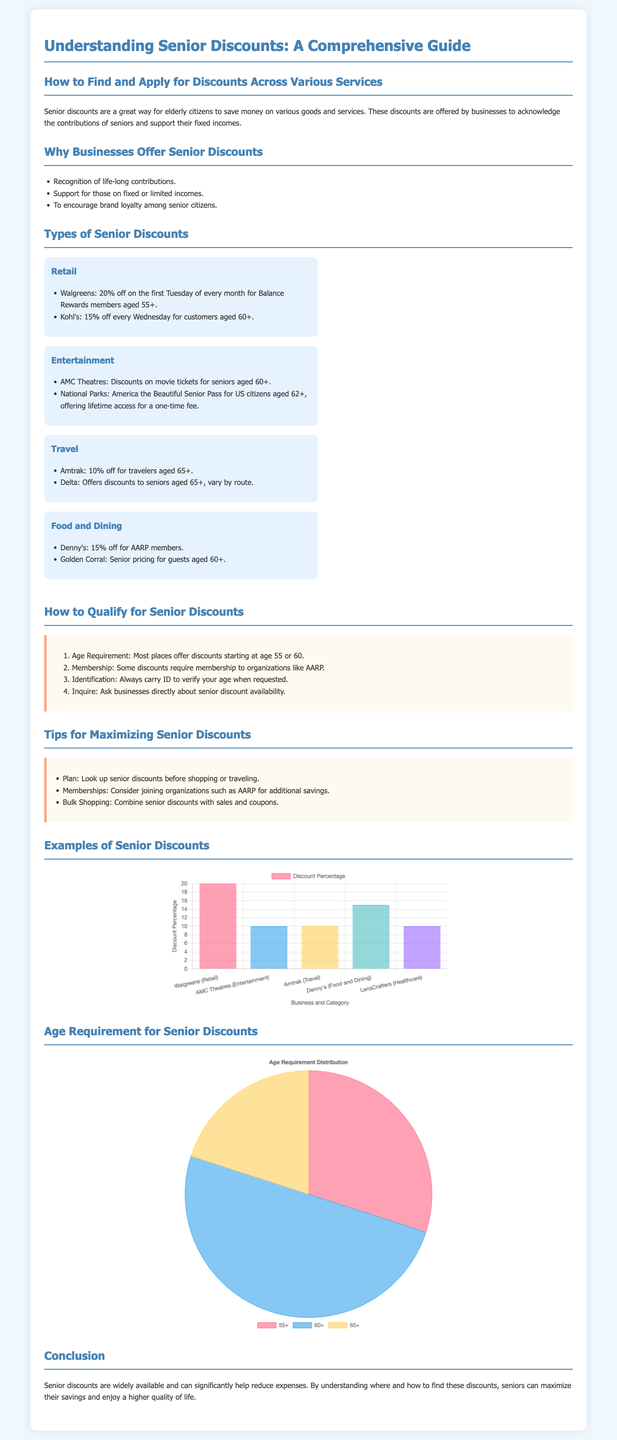What is the percentage discount offered by Walgreens? Walgreens offers a 20% discount on the first Tuesday of every month for Balance Rewards members aged 55+.
Answer: 20% What age do seniors typically qualify for discounts at Denny's? Denny's offers a 15% discount for AARP members, usually starting at age 55 or 60.
Answer: 60+ Which category does the National Parks discount fall under? The National Parks discount for seniors falls under the Entertainment category.
Answer: Entertainment What percentage discount does Amtrak provide for seniors? Amtrak offers a 10% discount for travelers aged 65 and older.
Answer: 10% What is the age distribution percentage for the 60+ category? The age requirement distribution shows that 50% of discounts are available for individuals aged 60 and older.
Answer: 50% How many steps are mentioned for qualifying for senior discounts? There are four steps listed for qualifying for senior discounts in the document.
Answer: 4 Which organization is recommended for additional savings opportunities? AARP is mentioned as a recommended organization for additional savings.
Answer: AARP What type of chart visualizes the discount percentages across business categories? A bar chart is used to visualize the discount percentages across various business categories.
Answer: Bar Chart What type of chart shows the age requirement distribution? A pie chart is used to show the age requirement distribution for senior discounts.
Answer: Pie Chart 